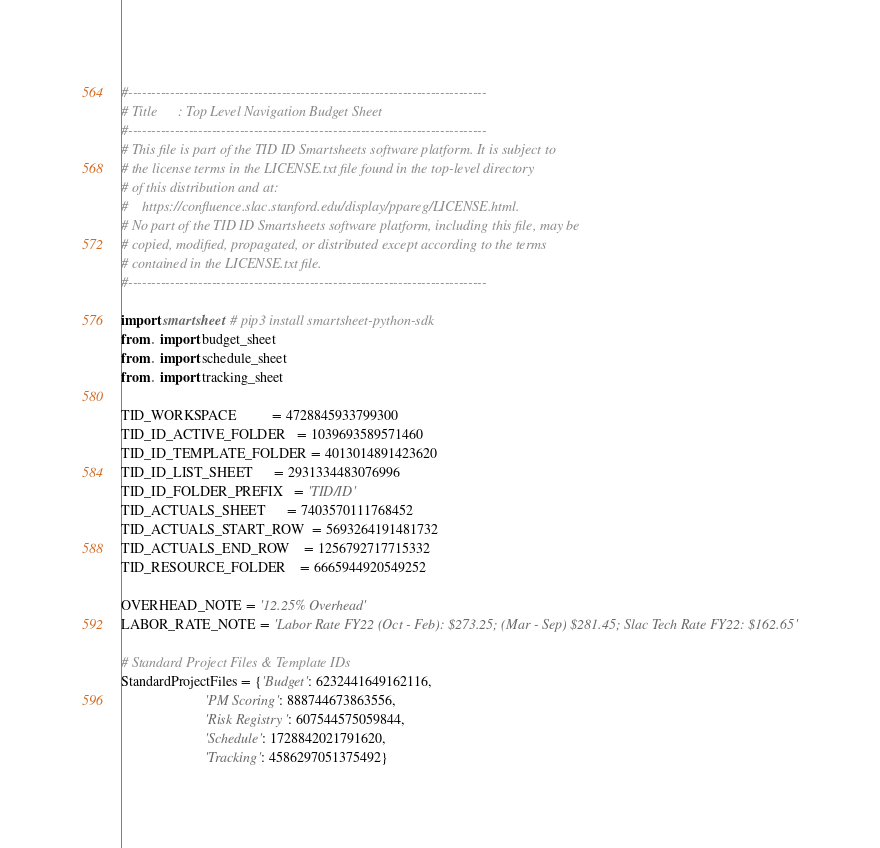<code> <loc_0><loc_0><loc_500><loc_500><_Python_>#-----------------------------------------------------------------------------
# Title      : Top Level Navigation Budget Sheet
#-----------------------------------------------------------------------------
# This file is part of the TID ID Smartsheets software platform. It is subject to
# the license terms in the LICENSE.txt file found in the top-level directory
# of this distribution and at:
#    https://confluence.slac.stanford.edu/display/ppareg/LICENSE.html.
# No part of the TID ID Smartsheets software platform, including this file, may be
# copied, modified, propagated, or distributed except according to the terms
# contained in the LICENSE.txt file.
#-----------------------------------------------------------------------------

import smartsheet  # pip3 install smartsheet-python-sdk
from . import budget_sheet
from . import schedule_sheet
from . import tracking_sheet

TID_WORKSPACE          = 4728845933799300
TID_ID_ACTIVE_FOLDER   = 1039693589571460
TID_ID_TEMPLATE_FOLDER = 4013014891423620
TID_ID_LIST_SHEET      = 2931334483076996
TID_ID_FOLDER_PREFIX   = 'TID/ID'
TID_ACTUALS_SHEET      = 7403570111768452
TID_ACTUALS_START_ROW  = 5693264191481732
TID_ACTUALS_END_ROW    = 1256792717715332
TID_RESOURCE_FOLDER    = 6665944920549252

OVERHEAD_NOTE = '12.25% Overhead'
LABOR_RATE_NOTE = 'Labor Rate FY22 (Oct - Feb): $273.25; (Mar - Sep) $281.45; Slac Tech Rate FY22: $162.65'

# Standard Project Files & Template IDs
StandardProjectFiles = {'Budget': 6232441649162116,
                        'PM Scoring': 888744673863556,
                        'Risk Registry': 607544575059844,
                        'Schedule': 1728842021791620,
                        'Tracking': 4586297051375492}

</code> 